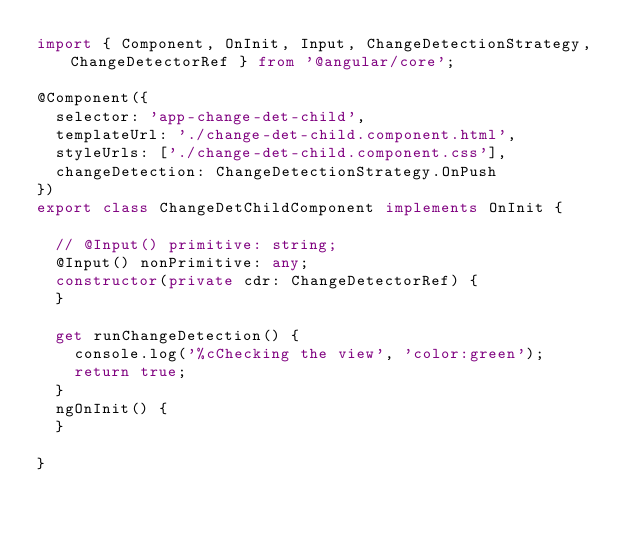<code> <loc_0><loc_0><loc_500><loc_500><_TypeScript_>import { Component, OnInit, Input, ChangeDetectionStrategy, ChangeDetectorRef } from '@angular/core';

@Component({
  selector: 'app-change-det-child',
  templateUrl: './change-det-child.component.html',
  styleUrls: ['./change-det-child.component.css'],
  changeDetection: ChangeDetectionStrategy.OnPush
})
export class ChangeDetChildComponent implements OnInit {

  // @Input() primitive: string;
  @Input() nonPrimitive: any;
  constructor(private cdr: ChangeDetectorRef) {
  }

  get runChangeDetection() {
    console.log('%cChecking the view', 'color:green');
    return true;
  }
  ngOnInit() {
  }

}
</code> 